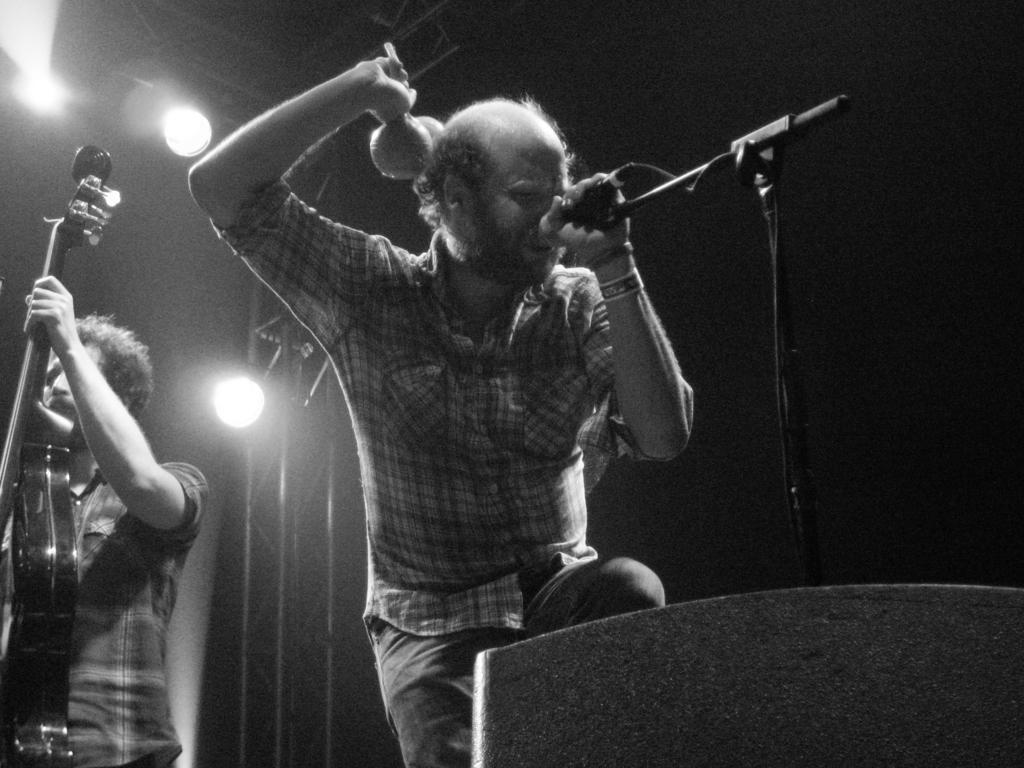How many people are in the image? There are two men in the image. What are the two men doing in the image? One of the men is playing the guitar, and the other man is singing with a microphone. What can be seen at the top of the image? There are two lights at the top of the image. How many cows are visible in the image? There are no cows present in the image. What is the wall made of in the image? There is no wall present in the image. 